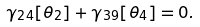Convert formula to latex. <formula><loc_0><loc_0><loc_500><loc_500>\gamma _ { 2 4 } [ \theta _ { 2 } ] + \gamma _ { 3 9 } [ \theta _ { 4 } ] = 0 .</formula> 